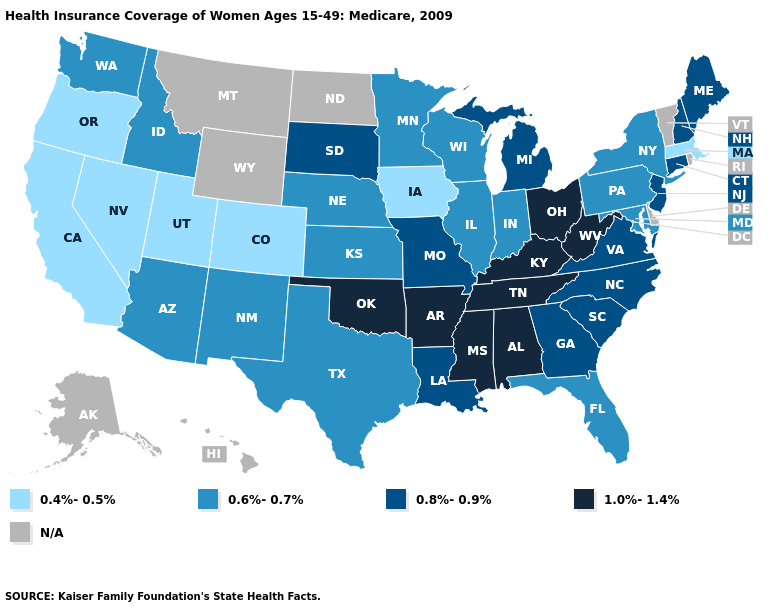Does California have the highest value in the West?
Write a very short answer. No. Is the legend a continuous bar?
Write a very short answer. No. What is the lowest value in states that border South Dakota?
Give a very brief answer. 0.4%-0.5%. Is the legend a continuous bar?
Concise answer only. No. Name the states that have a value in the range N/A?
Give a very brief answer. Alaska, Delaware, Hawaii, Montana, North Dakota, Rhode Island, Vermont, Wyoming. Name the states that have a value in the range 0.6%-0.7%?
Short answer required. Arizona, Florida, Idaho, Illinois, Indiana, Kansas, Maryland, Minnesota, Nebraska, New Mexico, New York, Pennsylvania, Texas, Washington, Wisconsin. What is the value of North Dakota?
Concise answer only. N/A. What is the value of New Jersey?
Give a very brief answer. 0.8%-0.9%. What is the value of Massachusetts?
Be succinct. 0.4%-0.5%. Which states hav the highest value in the MidWest?
Be succinct. Ohio. What is the highest value in the USA?
Short answer required. 1.0%-1.4%. Which states hav the highest value in the MidWest?
Short answer required. Ohio. What is the lowest value in states that border North Carolina?
Give a very brief answer. 0.8%-0.9%. What is the lowest value in the Northeast?
Be succinct. 0.4%-0.5%. 